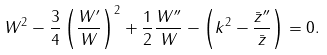Convert formula to latex. <formula><loc_0><loc_0><loc_500><loc_500>W ^ { 2 } - \frac { 3 } { 4 } \left ( \frac { W ^ { \prime } } { W } \right ) ^ { 2 } + \frac { 1 } { 2 } \frac { W ^ { \prime \prime } } { W } - \left ( k ^ { 2 } - \frac { \bar { z } ^ { \prime \prime } } { \bar { z } } \right ) = 0 .</formula> 